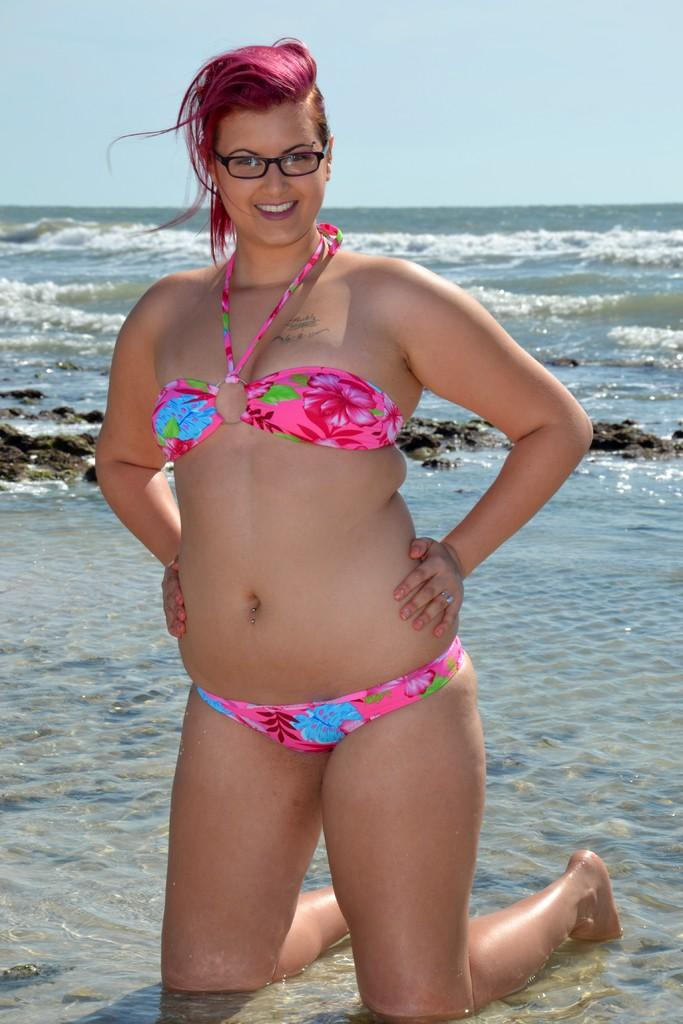What is present in the image? There is a person and water visible in the image. What else can be seen in the image besides the person and water? The sky is visible in the image. What type of stone is being used by the person in the image? There is no stone present in the image. 